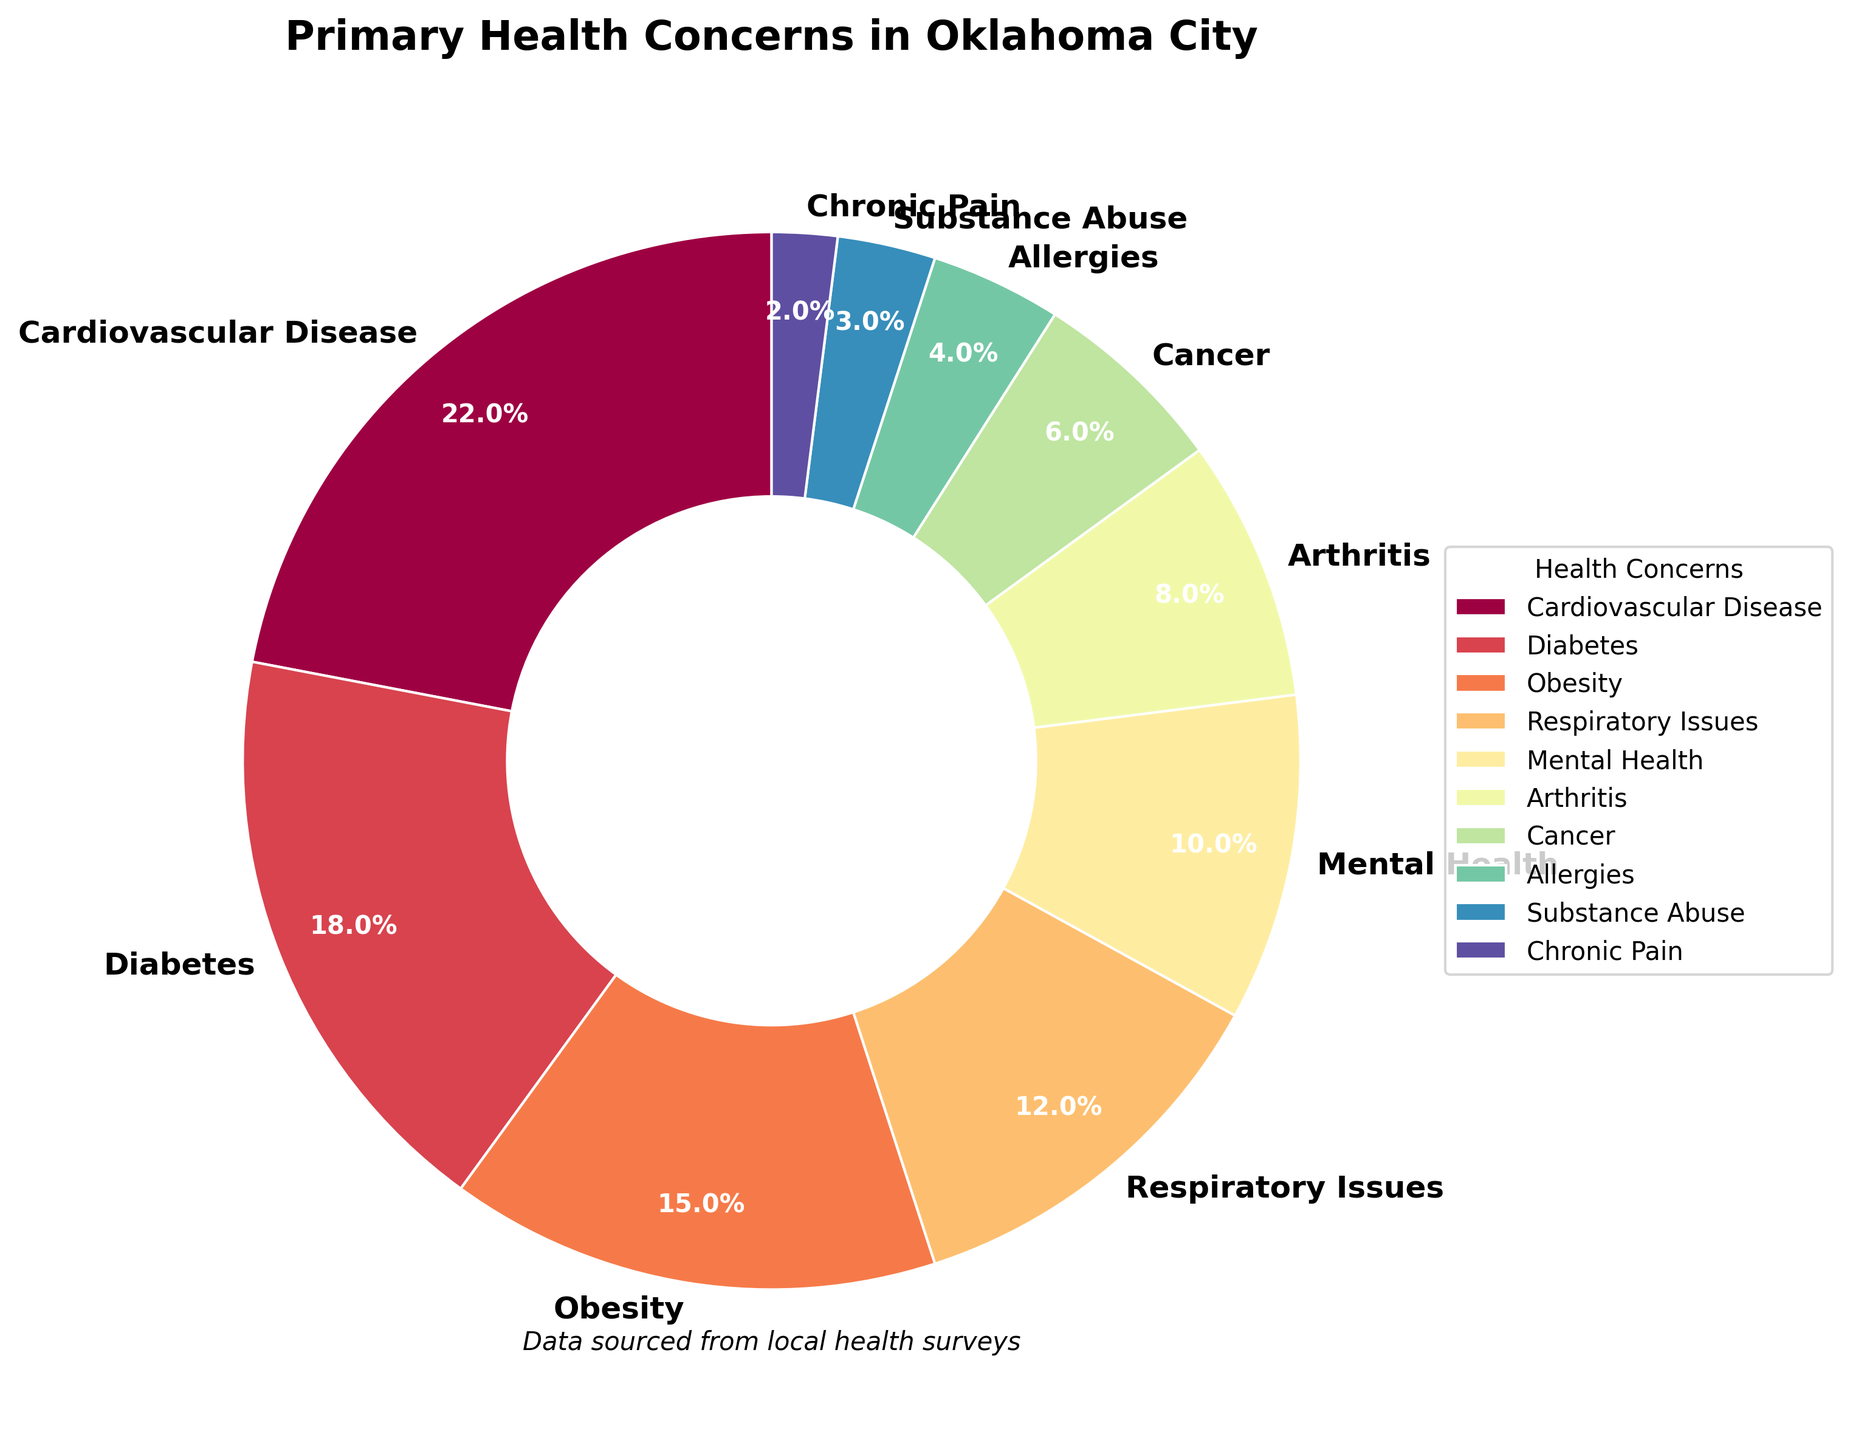What's the largest health concern among Oklahoma City residents? To find the largest health concern, look at the percentages in the pie chart and identify the segment with the highest percentage. Cardiovascular Disease has the highest percentage at 22%.
Answer: Cardiovascular Disease What is the combined percentage of residents concerned with Diabetes and Obesity? Add the percentages of Diabetes (18%) and Obesity (15%). The sum is 18% + 15% = 33%.
Answer: 33% Which health concern has the smallest percentage and what is it? Look for the smallest segment in the pie chart. Chronic Pain, at 2%, is the smallest health concern.
Answer: Chronic Pain, 2% Is the percentage of residents concerned with Respiratory Issues greater than those concerned with Mental Health? Compare the percentages of Respiratory Issues (12%) and Mental Health (10%). Since 12% > 10%, Respiratory Issues have a greater percentage.
Answer: Yes What is the difference in percentage between Cardiovascular Disease and Cancer? Subtract the percentage of Cancer (6%) from the percentage of Cardiovascular Disease (22%). The difference is 22% - 6% = 16%.
Answer: 16% What percentage of residents are concerned with health issues other than Cardiovascular Disease and Diabetes? Subtract the combined percentage of Cardiovascular Disease (22%) and Diabetes (18%) from 100%. The percentage is 100% - (22% + 18%) = 60%.
Answer: 60% Which health concern categories have percentages that add up to greater than 30% when combined? Sum the percentages of different categories and identify combinations that exceed 30%. For example, Respiratory Issues (12%) and Obesity (15%) together are 27%, but when you add Allergies (4%), the total becomes 31%.
Answer: Respiratory Issues, Obesity, Allergies What is the average percentage of residents concerned with Allergic Reactions, Substance Abuse, and Chronic Pain? Add the percentages of Allergies (4%), Substance Abuse (3%), and Chronic Pain (2%), then divide by the number of categories. The average is (4% + 3% + 2%) / 3 = 3%.
Answer: 3% How many health concerns have a percentage lower than 10%? Identify all segments with less than 10% in the pie chart: Cancer (6%), Allergies (4%), Substance Abuse (3%), Chronic Pain (2%). There are 4 such health concerns.
Answer: 4 Which segment in the pie chart appears in a dark reddish color? Look for the segment with the specific visual attribute of a dark reddish color. The Cardiovascular Disease segment is shown in dark red.
Answer: Cardiovascular Disease 